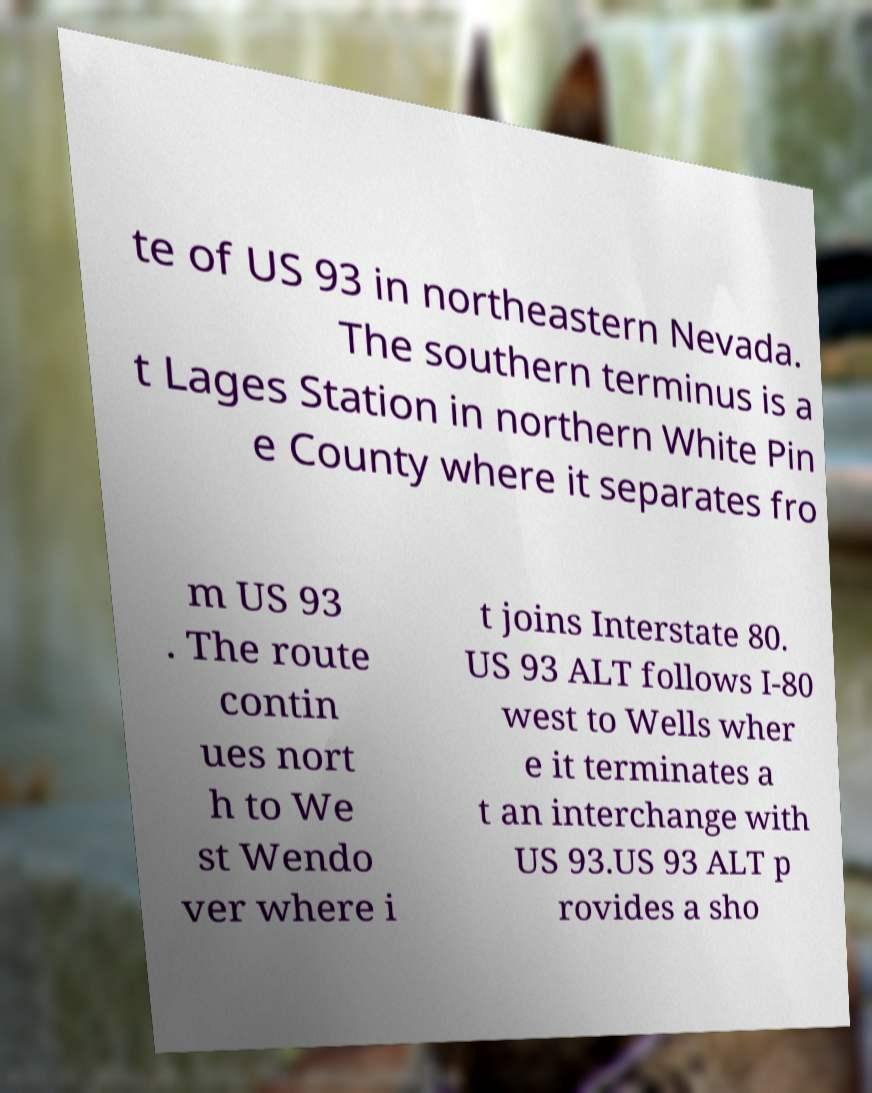Could you extract and type out the text from this image? te of US 93 in northeastern Nevada. The southern terminus is a t Lages Station in northern White Pin e County where it separates fro m US 93 . The route contin ues nort h to We st Wendo ver where i t joins Interstate 80. US 93 ALT follows I-80 west to Wells wher e it terminates a t an interchange with US 93.US 93 ALT p rovides a sho 